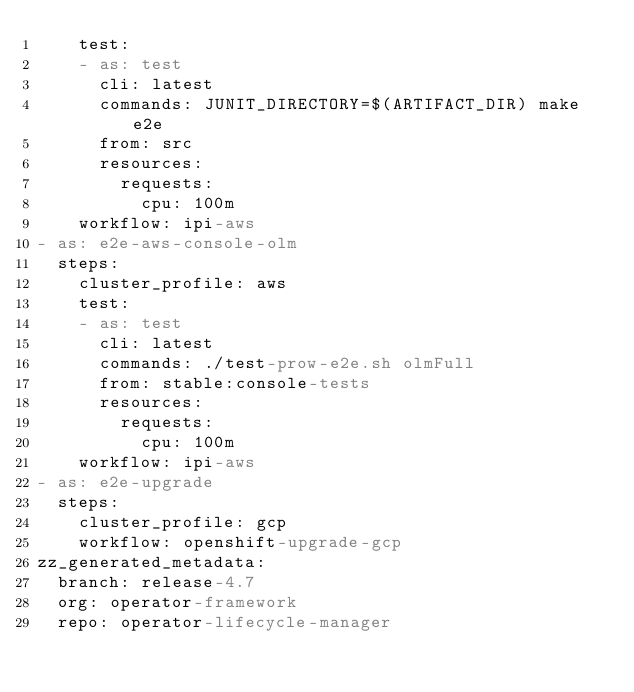<code> <loc_0><loc_0><loc_500><loc_500><_YAML_>    test:
    - as: test
      cli: latest
      commands: JUNIT_DIRECTORY=$(ARTIFACT_DIR) make e2e
      from: src
      resources:
        requests:
          cpu: 100m
    workflow: ipi-aws
- as: e2e-aws-console-olm
  steps:
    cluster_profile: aws
    test:
    - as: test
      cli: latest
      commands: ./test-prow-e2e.sh olmFull
      from: stable:console-tests
      resources:
        requests:
          cpu: 100m
    workflow: ipi-aws
- as: e2e-upgrade
  steps:
    cluster_profile: gcp
    workflow: openshift-upgrade-gcp
zz_generated_metadata:
  branch: release-4.7
  org: operator-framework
  repo: operator-lifecycle-manager
</code> 